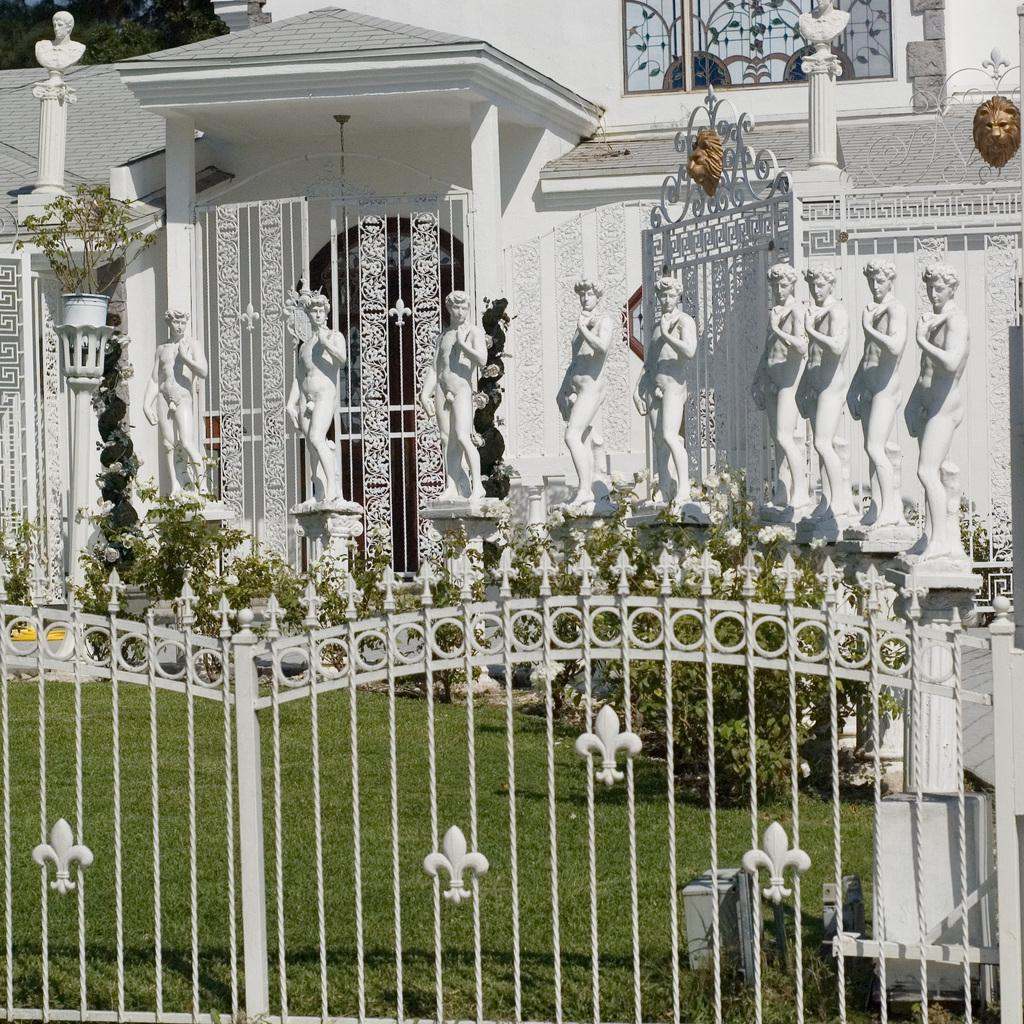What is the main structure visible in the image? There is a gate in the image. What type of vegetation can be seen in the image? There is grass and plants visible in the image. What can be seen in the background of the image? There are sculptures and a building in the background of the image. What type of water feature can be seen in the image? There is no water feature present in the image. What question is being asked by the person in the image? There is no person present in the image, and therefore no question being asked. 